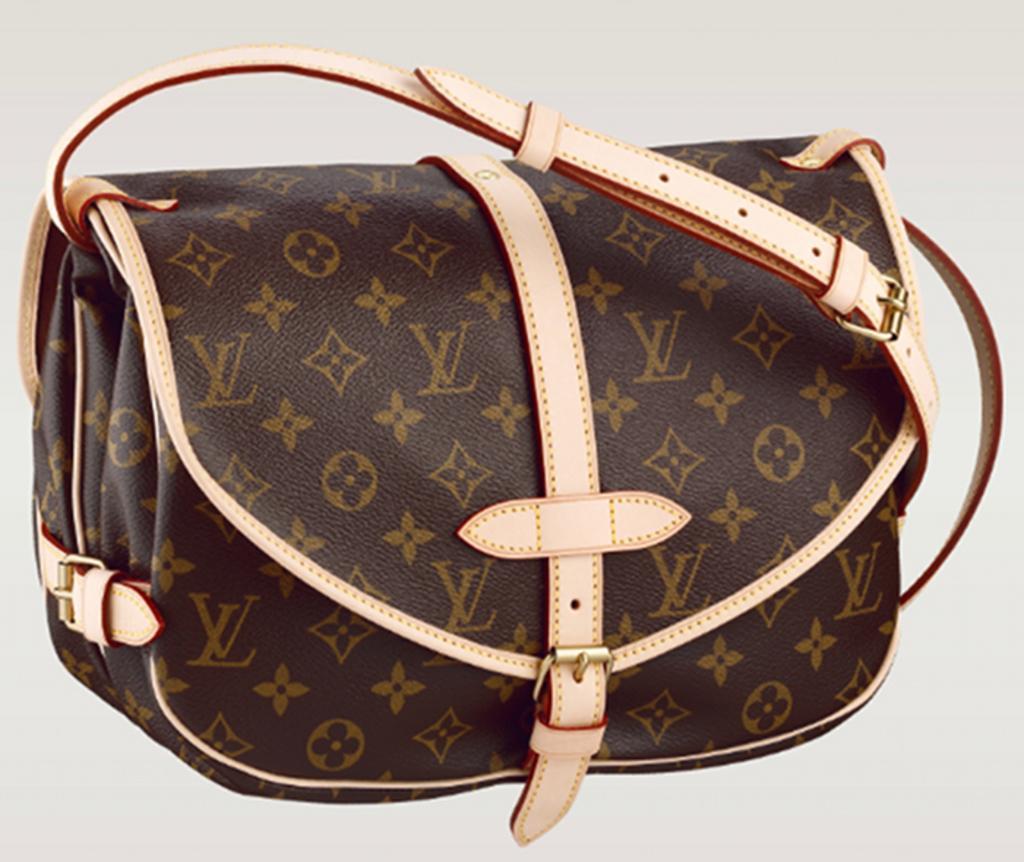Could you give a brief overview of what you see in this image? In this picture there is a bag of brown colour with cream colour belt. 